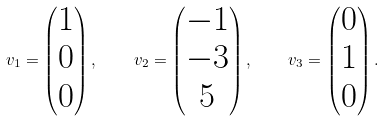Convert formula to latex. <formula><loc_0><loc_0><loc_500><loc_500>v _ { 1 } = \begin{pmatrix} 1 \\ 0 \\ 0 \end{pmatrix} , \quad v _ { 2 } = \begin{pmatrix} - 1 \\ - 3 \\ 5 \end{pmatrix} , \quad v _ { 3 } = \begin{pmatrix} 0 \\ 1 \\ 0 \end{pmatrix} .</formula> 